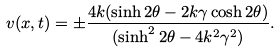<formula> <loc_0><loc_0><loc_500><loc_500>v ( x , t ) = \pm \frac { 4 k ( \sinh 2 \theta - 2 k \gamma \cosh 2 \theta ) } { ( \sinh ^ { 2 } 2 \theta - 4 k ^ { 2 } \gamma ^ { 2 } ) } .</formula> 